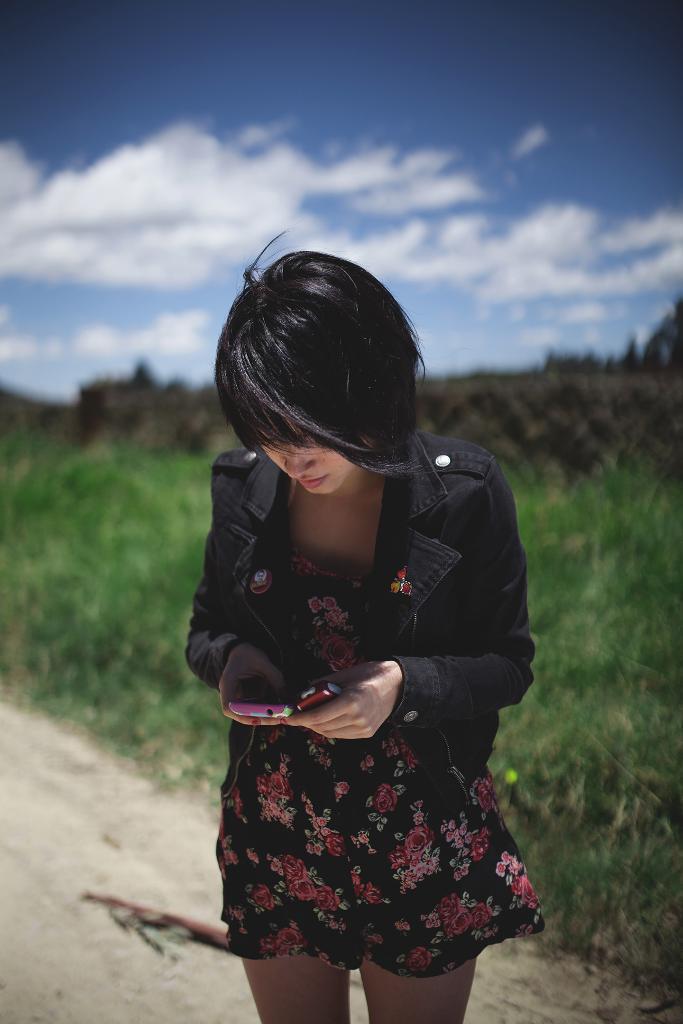How would you summarize this image in a sentence or two? In this image I can see a woman wearing black and pink colored dress is standing and holding mobiles in her hand. In the background I can see the ground, some grass, a black colored object and the sky. 